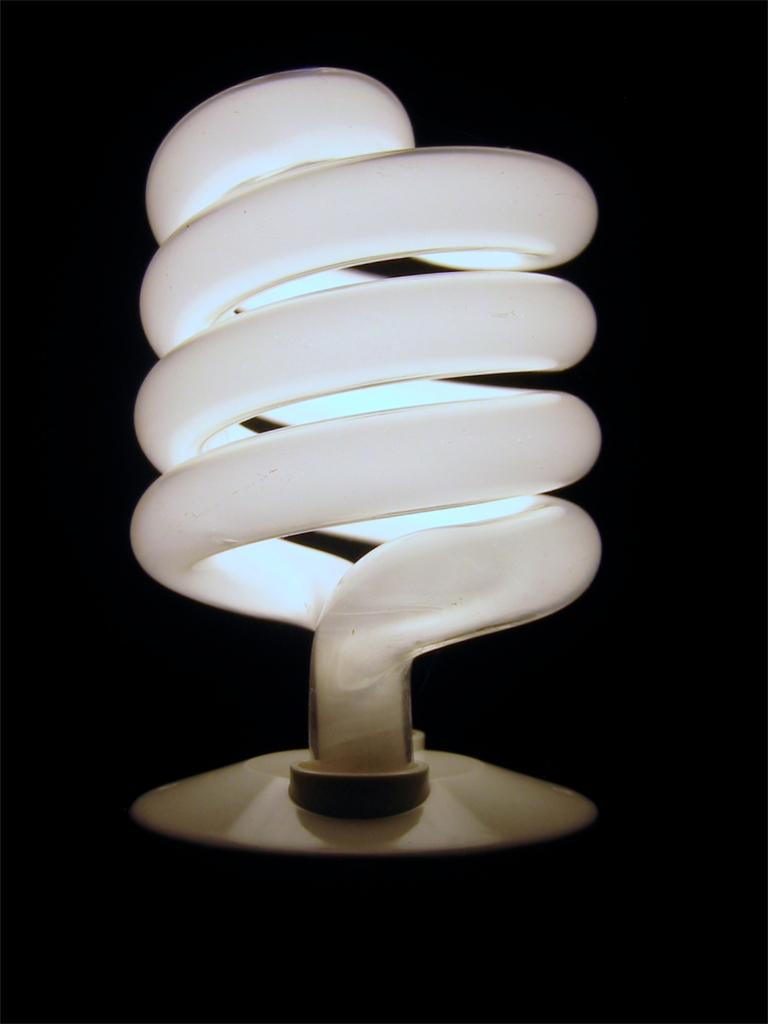What is the main source of light in the image? There is a light in the image. How would you describe the overall lighting in the image? The background of the image is dark. How does the light help the person pay attention during dinner in the image? There is no person or dinner present in the image, so it is not possible to determine how the light might affect attention during dinner. 